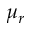Convert formula to latex. <formula><loc_0><loc_0><loc_500><loc_500>\mu _ { r }</formula> 